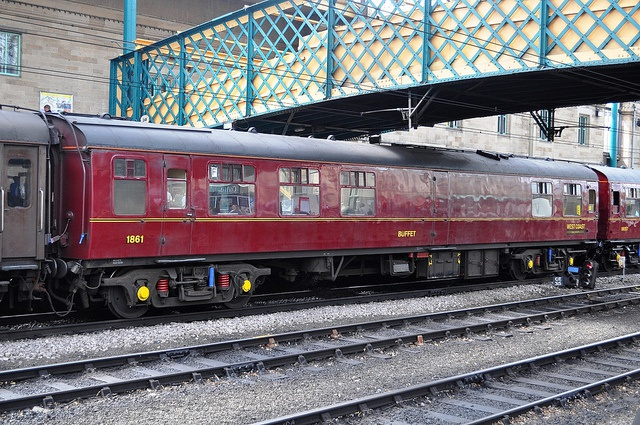Describe the objects in this image and their specific colors. I can see train in gray, black, darkgray, and maroon tones and traffic light in gray, black, and maroon tones in this image. 